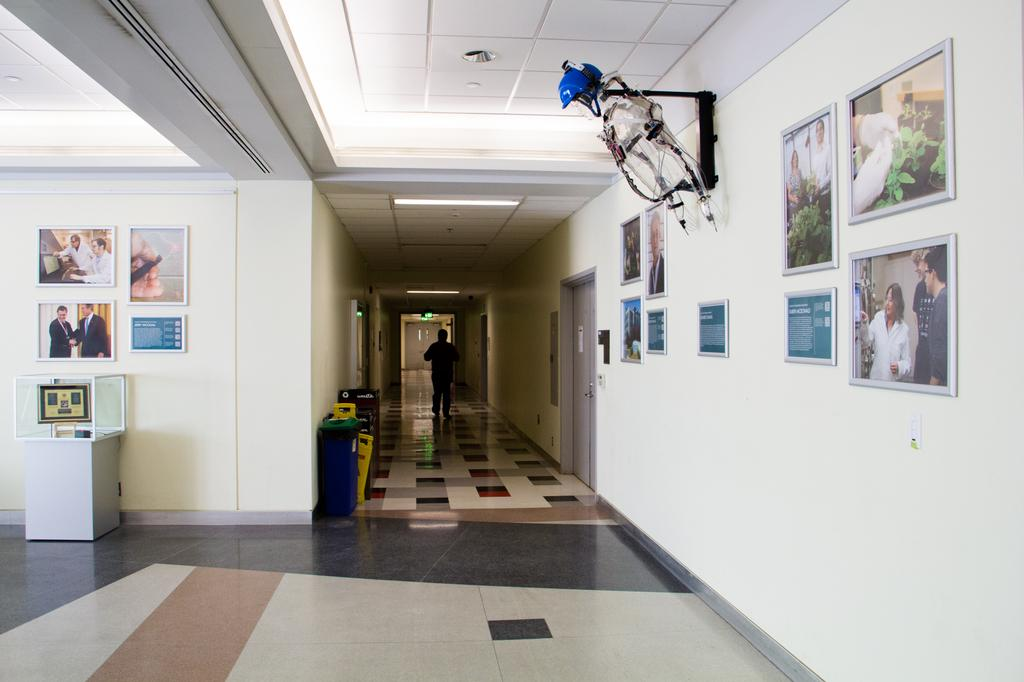What is the person in the image doing? The person in the image is walking. On what surface is the person walking? The person is walking on the floor. What type of containers can be seen in the image? There are bins in the image. What other object can be seen in the image? There is a box in the image. What type of protective gear is visible in the image? A helmet is visible in the image. What type of openings are present in the image? There are doors in the image. What type of illumination is present in the image? Lights are present in the image. What type of decorative items are on the walls in the image? There are frames on the walls in the image. Can you describe the unspecified objects in the image? Unfortunately, the facts provided do not specify the nature of the unspecified objects in the image. What type of air can be seen flowing through the image? There is no air visible in the image. What type of wave can be seen in the image? There is no wave visible in the image. What type of steel structure is present in the image? There is no steel structure present in the image. 